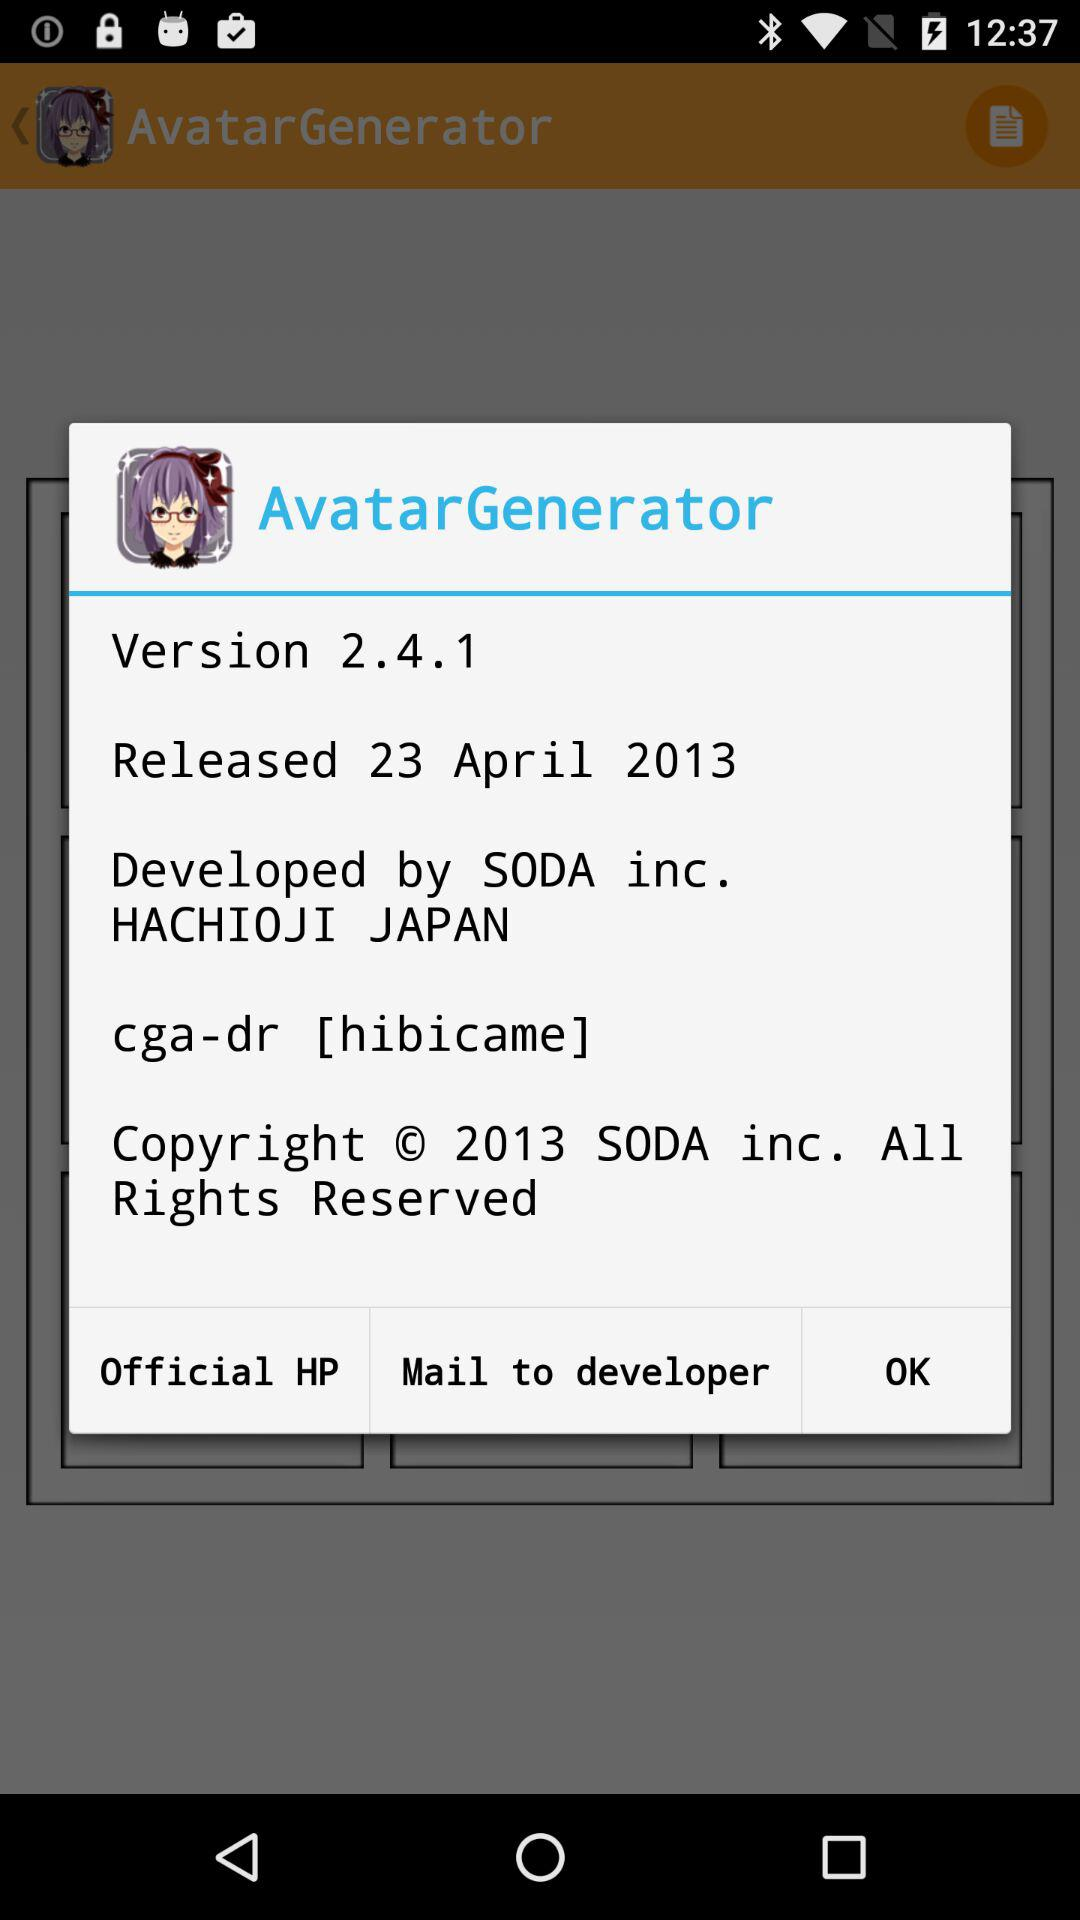What is the app name? The app name is "Avatar Maker -Profile creator-". 